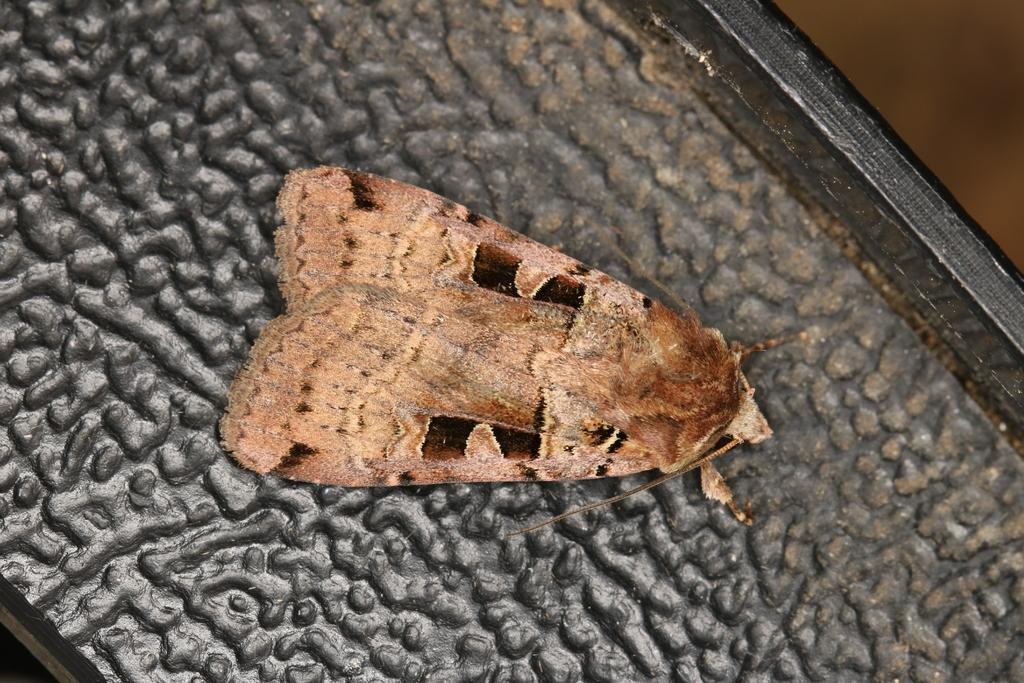What type of living organism can be seen in the image? There is an insect in the image. Can you describe the color of the insect? The insect is colored brown. What type of vegetable is the insect using to cook a meal in the image? There is no vegetable or cooking activity present in the image; it features an insect colored brown. What type of drug is the insect carrying in the image? There is no drug present in the image; it features an insect colored brown. 